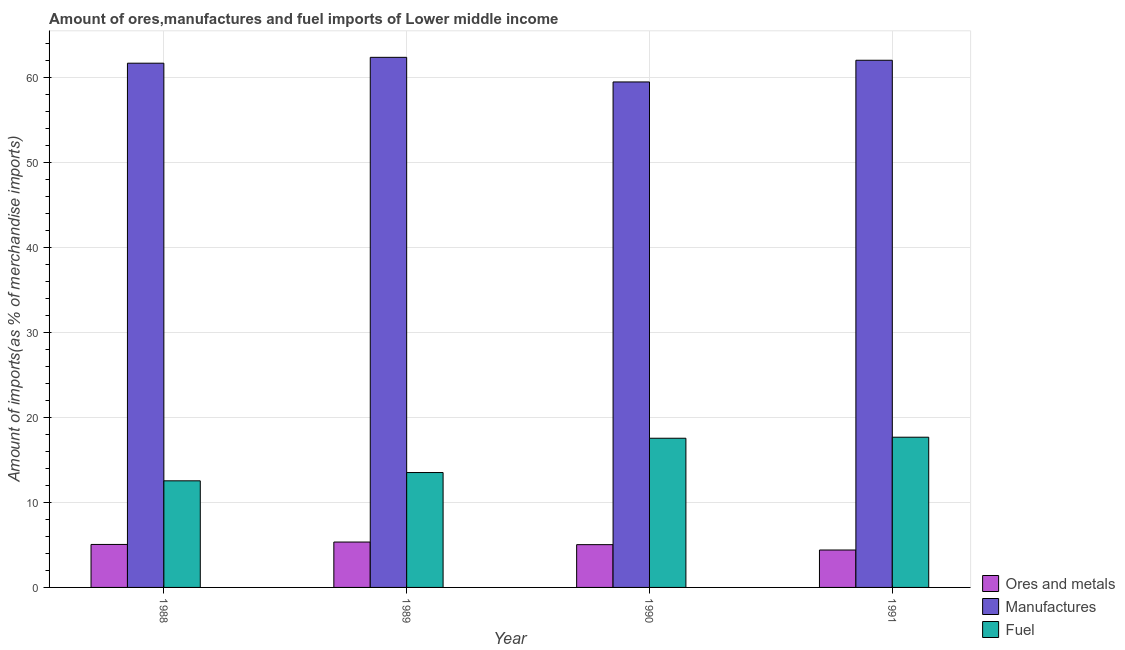How many bars are there on the 3rd tick from the left?
Provide a succinct answer. 3. How many bars are there on the 3rd tick from the right?
Ensure brevity in your answer.  3. What is the percentage of ores and metals imports in 1990?
Offer a terse response. 5.03. Across all years, what is the maximum percentage of ores and metals imports?
Make the answer very short. 5.34. Across all years, what is the minimum percentage of manufactures imports?
Your answer should be compact. 59.48. What is the total percentage of manufactures imports in the graph?
Your response must be concise. 245.57. What is the difference between the percentage of fuel imports in 1990 and that in 1991?
Offer a very short reply. -0.12. What is the difference between the percentage of fuel imports in 1988 and the percentage of ores and metals imports in 1990?
Offer a very short reply. -5.01. What is the average percentage of manufactures imports per year?
Your answer should be compact. 61.39. In how many years, is the percentage of ores and metals imports greater than 56 %?
Your response must be concise. 0. What is the ratio of the percentage of manufactures imports in 1990 to that in 1991?
Keep it short and to the point. 0.96. Is the percentage of fuel imports in 1988 less than that in 1990?
Offer a very short reply. Yes. What is the difference between the highest and the second highest percentage of manufactures imports?
Provide a short and direct response. 0.34. What is the difference between the highest and the lowest percentage of ores and metals imports?
Ensure brevity in your answer.  0.94. In how many years, is the percentage of manufactures imports greater than the average percentage of manufactures imports taken over all years?
Keep it short and to the point. 3. Is the sum of the percentage of ores and metals imports in 1989 and 1990 greater than the maximum percentage of manufactures imports across all years?
Keep it short and to the point. Yes. What does the 3rd bar from the left in 1991 represents?
Keep it short and to the point. Fuel. What does the 2nd bar from the right in 1988 represents?
Your answer should be compact. Manufactures. Is it the case that in every year, the sum of the percentage of ores and metals imports and percentage of manufactures imports is greater than the percentage of fuel imports?
Your answer should be compact. Yes. How many bars are there?
Give a very brief answer. 12. Are all the bars in the graph horizontal?
Provide a short and direct response. No. Does the graph contain any zero values?
Provide a short and direct response. No. Does the graph contain grids?
Give a very brief answer. Yes. Where does the legend appear in the graph?
Your answer should be very brief. Bottom right. What is the title of the graph?
Offer a terse response. Amount of ores,manufactures and fuel imports of Lower middle income. Does "Consumption Tax" appear as one of the legend labels in the graph?
Your answer should be compact. No. What is the label or title of the X-axis?
Your answer should be compact. Year. What is the label or title of the Y-axis?
Keep it short and to the point. Amount of imports(as % of merchandise imports). What is the Amount of imports(as % of merchandise imports) of Ores and metals in 1988?
Provide a succinct answer. 5.06. What is the Amount of imports(as % of merchandise imports) in Manufactures in 1988?
Offer a terse response. 61.68. What is the Amount of imports(as % of merchandise imports) of Fuel in 1988?
Keep it short and to the point. 12.54. What is the Amount of imports(as % of merchandise imports) of Ores and metals in 1989?
Provide a short and direct response. 5.34. What is the Amount of imports(as % of merchandise imports) of Manufactures in 1989?
Your answer should be compact. 62.38. What is the Amount of imports(as % of merchandise imports) in Fuel in 1989?
Your answer should be very brief. 13.52. What is the Amount of imports(as % of merchandise imports) of Ores and metals in 1990?
Provide a succinct answer. 5.03. What is the Amount of imports(as % of merchandise imports) in Manufactures in 1990?
Keep it short and to the point. 59.48. What is the Amount of imports(as % of merchandise imports) in Fuel in 1990?
Offer a terse response. 17.55. What is the Amount of imports(as % of merchandise imports) of Ores and metals in 1991?
Your response must be concise. 4.4. What is the Amount of imports(as % of merchandise imports) of Manufactures in 1991?
Offer a very short reply. 62.03. What is the Amount of imports(as % of merchandise imports) of Fuel in 1991?
Make the answer very short. 17.68. Across all years, what is the maximum Amount of imports(as % of merchandise imports) of Ores and metals?
Your answer should be very brief. 5.34. Across all years, what is the maximum Amount of imports(as % of merchandise imports) in Manufactures?
Make the answer very short. 62.38. Across all years, what is the maximum Amount of imports(as % of merchandise imports) of Fuel?
Your response must be concise. 17.68. Across all years, what is the minimum Amount of imports(as % of merchandise imports) of Ores and metals?
Provide a succinct answer. 4.4. Across all years, what is the minimum Amount of imports(as % of merchandise imports) of Manufactures?
Make the answer very short. 59.48. Across all years, what is the minimum Amount of imports(as % of merchandise imports) of Fuel?
Offer a terse response. 12.54. What is the total Amount of imports(as % of merchandise imports) in Ores and metals in the graph?
Your response must be concise. 19.83. What is the total Amount of imports(as % of merchandise imports) in Manufactures in the graph?
Your response must be concise. 245.57. What is the total Amount of imports(as % of merchandise imports) of Fuel in the graph?
Ensure brevity in your answer.  61.29. What is the difference between the Amount of imports(as % of merchandise imports) in Ores and metals in 1988 and that in 1989?
Ensure brevity in your answer.  -0.28. What is the difference between the Amount of imports(as % of merchandise imports) in Manufactures in 1988 and that in 1989?
Offer a very short reply. -0.69. What is the difference between the Amount of imports(as % of merchandise imports) of Fuel in 1988 and that in 1989?
Ensure brevity in your answer.  -0.97. What is the difference between the Amount of imports(as % of merchandise imports) in Ores and metals in 1988 and that in 1990?
Provide a succinct answer. 0.03. What is the difference between the Amount of imports(as % of merchandise imports) of Manufactures in 1988 and that in 1990?
Ensure brevity in your answer.  2.21. What is the difference between the Amount of imports(as % of merchandise imports) of Fuel in 1988 and that in 1990?
Make the answer very short. -5.01. What is the difference between the Amount of imports(as % of merchandise imports) of Ores and metals in 1988 and that in 1991?
Offer a very short reply. 0.65. What is the difference between the Amount of imports(as % of merchandise imports) in Manufactures in 1988 and that in 1991?
Offer a terse response. -0.35. What is the difference between the Amount of imports(as % of merchandise imports) of Fuel in 1988 and that in 1991?
Your answer should be compact. -5.13. What is the difference between the Amount of imports(as % of merchandise imports) in Ores and metals in 1989 and that in 1990?
Your response must be concise. 0.31. What is the difference between the Amount of imports(as % of merchandise imports) in Manufactures in 1989 and that in 1990?
Your answer should be compact. 2.9. What is the difference between the Amount of imports(as % of merchandise imports) of Fuel in 1989 and that in 1990?
Your response must be concise. -4.04. What is the difference between the Amount of imports(as % of merchandise imports) in Ores and metals in 1989 and that in 1991?
Your answer should be very brief. 0.94. What is the difference between the Amount of imports(as % of merchandise imports) in Manufactures in 1989 and that in 1991?
Offer a very short reply. 0.34. What is the difference between the Amount of imports(as % of merchandise imports) in Fuel in 1989 and that in 1991?
Give a very brief answer. -4.16. What is the difference between the Amount of imports(as % of merchandise imports) in Ores and metals in 1990 and that in 1991?
Provide a succinct answer. 0.63. What is the difference between the Amount of imports(as % of merchandise imports) in Manufactures in 1990 and that in 1991?
Offer a very short reply. -2.55. What is the difference between the Amount of imports(as % of merchandise imports) of Fuel in 1990 and that in 1991?
Your answer should be compact. -0.12. What is the difference between the Amount of imports(as % of merchandise imports) in Ores and metals in 1988 and the Amount of imports(as % of merchandise imports) in Manufactures in 1989?
Give a very brief answer. -57.32. What is the difference between the Amount of imports(as % of merchandise imports) of Ores and metals in 1988 and the Amount of imports(as % of merchandise imports) of Fuel in 1989?
Keep it short and to the point. -8.46. What is the difference between the Amount of imports(as % of merchandise imports) of Manufactures in 1988 and the Amount of imports(as % of merchandise imports) of Fuel in 1989?
Offer a terse response. 48.17. What is the difference between the Amount of imports(as % of merchandise imports) in Ores and metals in 1988 and the Amount of imports(as % of merchandise imports) in Manufactures in 1990?
Offer a very short reply. -54.42. What is the difference between the Amount of imports(as % of merchandise imports) of Ores and metals in 1988 and the Amount of imports(as % of merchandise imports) of Fuel in 1990?
Provide a succinct answer. -12.5. What is the difference between the Amount of imports(as % of merchandise imports) in Manufactures in 1988 and the Amount of imports(as % of merchandise imports) in Fuel in 1990?
Offer a very short reply. 44.13. What is the difference between the Amount of imports(as % of merchandise imports) of Ores and metals in 1988 and the Amount of imports(as % of merchandise imports) of Manufactures in 1991?
Make the answer very short. -56.97. What is the difference between the Amount of imports(as % of merchandise imports) of Ores and metals in 1988 and the Amount of imports(as % of merchandise imports) of Fuel in 1991?
Offer a terse response. -12.62. What is the difference between the Amount of imports(as % of merchandise imports) in Manufactures in 1988 and the Amount of imports(as % of merchandise imports) in Fuel in 1991?
Make the answer very short. 44.01. What is the difference between the Amount of imports(as % of merchandise imports) of Ores and metals in 1989 and the Amount of imports(as % of merchandise imports) of Manufactures in 1990?
Ensure brevity in your answer.  -54.14. What is the difference between the Amount of imports(as % of merchandise imports) in Ores and metals in 1989 and the Amount of imports(as % of merchandise imports) in Fuel in 1990?
Provide a short and direct response. -12.21. What is the difference between the Amount of imports(as % of merchandise imports) of Manufactures in 1989 and the Amount of imports(as % of merchandise imports) of Fuel in 1990?
Ensure brevity in your answer.  44.82. What is the difference between the Amount of imports(as % of merchandise imports) of Ores and metals in 1989 and the Amount of imports(as % of merchandise imports) of Manufactures in 1991?
Give a very brief answer. -56.69. What is the difference between the Amount of imports(as % of merchandise imports) of Ores and metals in 1989 and the Amount of imports(as % of merchandise imports) of Fuel in 1991?
Offer a very short reply. -12.34. What is the difference between the Amount of imports(as % of merchandise imports) of Manufactures in 1989 and the Amount of imports(as % of merchandise imports) of Fuel in 1991?
Ensure brevity in your answer.  44.7. What is the difference between the Amount of imports(as % of merchandise imports) of Ores and metals in 1990 and the Amount of imports(as % of merchandise imports) of Manufactures in 1991?
Make the answer very short. -57. What is the difference between the Amount of imports(as % of merchandise imports) of Ores and metals in 1990 and the Amount of imports(as % of merchandise imports) of Fuel in 1991?
Offer a terse response. -12.64. What is the difference between the Amount of imports(as % of merchandise imports) in Manufactures in 1990 and the Amount of imports(as % of merchandise imports) in Fuel in 1991?
Keep it short and to the point. 41.8. What is the average Amount of imports(as % of merchandise imports) of Ores and metals per year?
Your answer should be compact. 4.96. What is the average Amount of imports(as % of merchandise imports) in Manufactures per year?
Make the answer very short. 61.39. What is the average Amount of imports(as % of merchandise imports) of Fuel per year?
Your answer should be very brief. 15.32. In the year 1988, what is the difference between the Amount of imports(as % of merchandise imports) in Ores and metals and Amount of imports(as % of merchandise imports) in Manufactures?
Your response must be concise. -56.63. In the year 1988, what is the difference between the Amount of imports(as % of merchandise imports) of Ores and metals and Amount of imports(as % of merchandise imports) of Fuel?
Your answer should be compact. -7.49. In the year 1988, what is the difference between the Amount of imports(as % of merchandise imports) of Manufactures and Amount of imports(as % of merchandise imports) of Fuel?
Your answer should be very brief. 49.14. In the year 1989, what is the difference between the Amount of imports(as % of merchandise imports) of Ores and metals and Amount of imports(as % of merchandise imports) of Manufactures?
Provide a short and direct response. -57.03. In the year 1989, what is the difference between the Amount of imports(as % of merchandise imports) of Ores and metals and Amount of imports(as % of merchandise imports) of Fuel?
Provide a short and direct response. -8.18. In the year 1989, what is the difference between the Amount of imports(as % of merchandise imports) in Manufactures and Amount of imports(as % of merchandise imports) in Fuel?
Keep it short and to the point. 48.86. In the year 1990, what is the difference between the Amount of imports(as % of merchandise imports) in Ores and metals and Amount of imports(as % of merchandise imports) in Manufactures?
Ensure brevity in your answer.  -54.45. In the year 1990, what is the difference between the Amount of imports(as % of merchandise imports) of Ores and metals and Amount of imports(as % of merchandise imports) of Fuel?
Provide a succinct answer. -12.52. In the year 1990, what is the difference between the Amount of imports(as % of merchandise imports) of Manufactures and Amount of imports(as % of merchandise imports) of Fuel?
Your response must be concise. 41.92. In the year 1991, what is the difference between the Amount of imports(as % of merchandise imports) of Ores and metals and Amount of imports(as % of merchandise imports) of Manufactures?
Offer a very short reply. -57.63. In the year 1991, what is the difference between the Amount of imports(as % of merchandise imports) in Ores and metals and Amount of imports(as % of merchandise imports) in Fuel?
Offer a very short reply. -13.27. In the year 1991, what is the difference between the Amount of imports(as % of merchandise imports) in Manufactures and Amount of imports(as % of merchandise imports) in Fuel?
Give a very brief answer. 44.35. What is the ratio of the Amount of imports(as % of merchandise imports) in Ores and metals in 1988 to that in 1989?
Keep it short and to the point. 0.95. What is the ratio of the Amount of imports(as % of merchandise imports) of Manufactures in 1988 to that in 1989?
Offer a terse response. 0.99. What is the ratio of the Amount of imports(as % of merchandise imports) in Fuel in 1988 to that in 1989?
Make the answer very short. 0.93. What is the ratio of the Amount of imports(as % of merchandise imports) of Ores and metals in 1988 to that in 1990?
Your answer should be compact. 1. What is the ratio of the Amount of imports(as % of merchandise imports) in Manufactures in 1988 to that in 1990?
Provide a succinct answer. 1.04. What is the ratio of the Amount of imports(as % of merchandise imports) in Fuel in 1988 to that in 1990?
Keep it short and to the point. 0.71. What is the ratio of the Amount of imports(as % of merchandise imports) in Ores and metals in 1988 to that in 1991?
Offer a terse response. 1.15. What is the ratio of the Amount of imports(as % of merchandise imports) in Fuel in 1988 to that in 1991?
Your response must be concise. 0.71. What is the ratio of the Amount of imports(as % of merchandise imports) of Ores and metals in 1989 to that in 1990?
Your answer should be compact. 1.06. What is the ratio of the Amount of imports(as % of merchandise imports) of Manufactures in 1989 to that in 1990?
Your response must be concise. 1.05. What is the ratio of the Amount of imports(as % of merchandise imports) in Fuel in 1989 to that in 1990?
Provide a short and direct response. 0.77. What is the ratio of the Amount of imports(as % of merchandise imports) of Ores and metals in 1989 to that in 1991?
Give a very brief answer. 1.21. What is the ratio of the Amount of imports(as % of merchandise imports) of Manufactures in 1989 to that in 1991?
Your answer should be compact. 1.01. What is the ratio of the Amount of imports(as % of merchandise imports) of Fuel in 1989 to that in 1991?
Your response must be concise. 0.76. What is the ratio of the Amount of imports(as % of merchandise imports) of Ores and metals in 1990 to that in 1991?
Your answer should be very brief. 1.14. What is the ratio of the Amount of imports(as % of merchandise imports) of Manufactures in 1990 to that in 1991?
Give a very brief answer. 0.96. What is the difference between the highest and the second highest Amount of imports(as % of merchandise imports) of Ores and metals?
Give a very brief answer. 0.28. What is the difference between the highest and the second highest Amount of imports(as % of merchandise imports) of Manufactures?
Provide a succinct answer. 0.34. What is the difference between the highest and the second highest Amount of imports(as % of merchandise imports) in Fuel?
Your response must be concise. 0.12. What is the difference between the highest and the lowest Amount of imports(as % of merchandise imports) in Ores and metals?
Ensure brevity in your answer.  0.94. What is the difference between the highest and the lowest Amount of imports(as % of merchandise imports) of Manufactures?
Give a very brief answer. 2.9. What is the difference between the highest and the lowest Amount of imports(as % of merchandise imports) in Fuel?
Give a very brief answer. 5.13. 